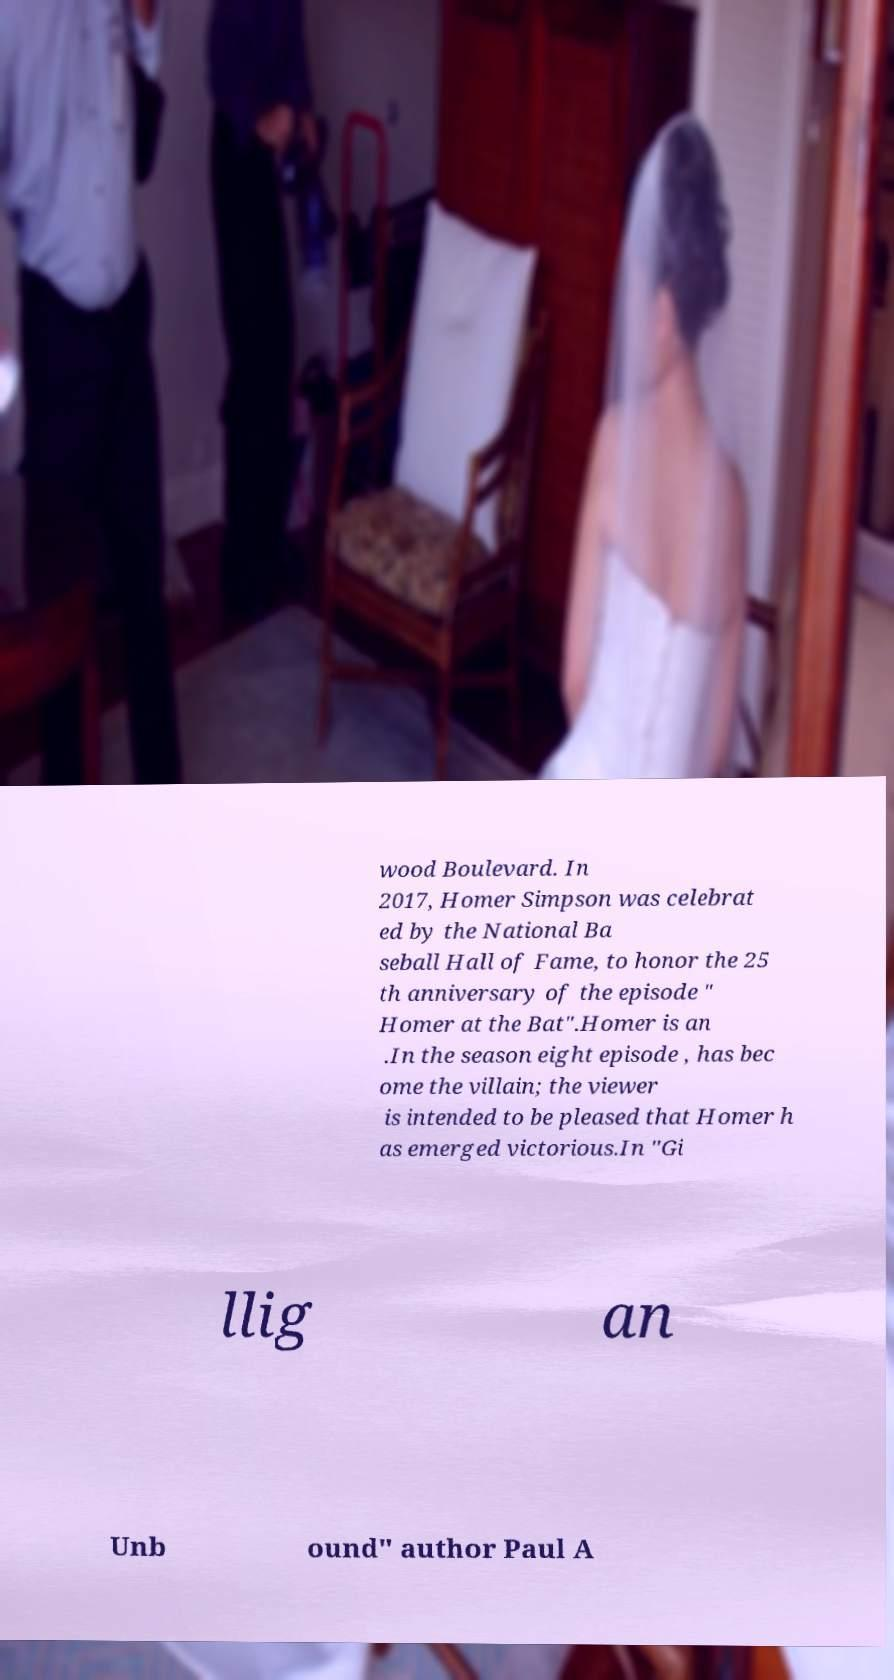Please read and relay the text visible in this image. What does it say? wood Boulevard. In 2017, Homer Simpson was celebrat ed by the National Ba seball Hall of Fame, to honor the 25 th anniversary of the episode " Homer at the Bat".Homer is an .In the season eight episode , has bec ome the villain; the viewer is intended to be pleased that Homer h as emerged victorious.In "Gi llig an Unb ound" author Paul A 